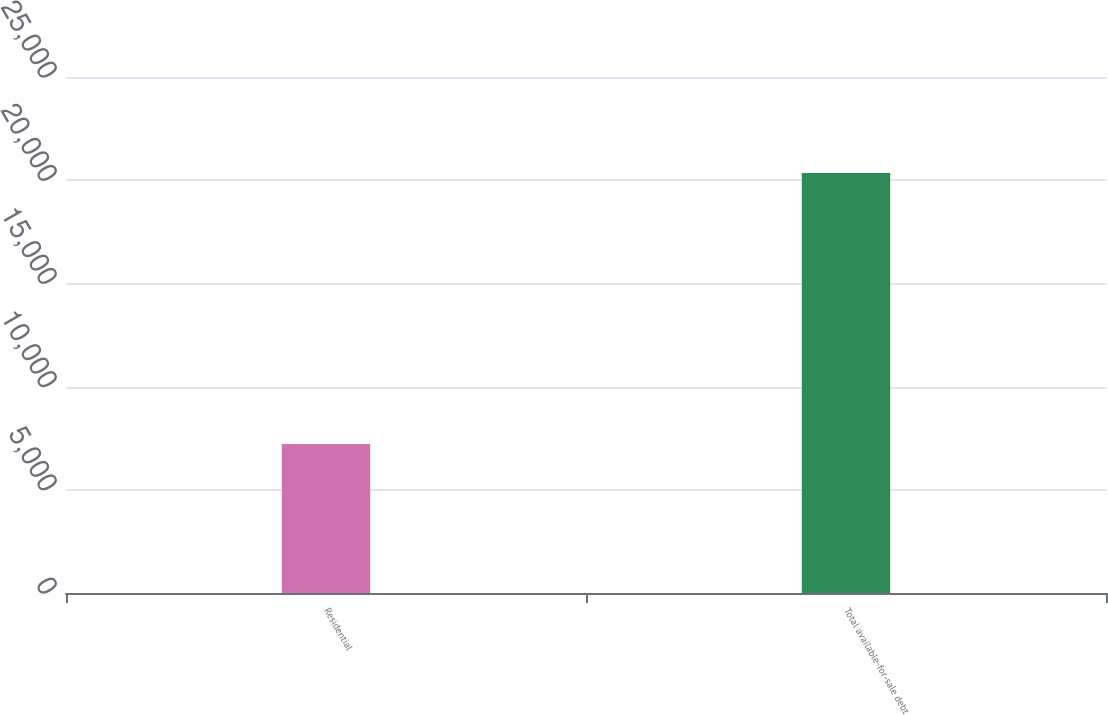<chart> <loc_0><loc_0><loc_500><loc_500><bar_chart><fcel>Residential<fcel>Total available-for-sale debt<nl><fcel>7216<fcel>20346<nl></chart> 